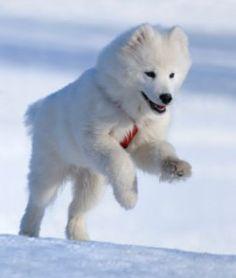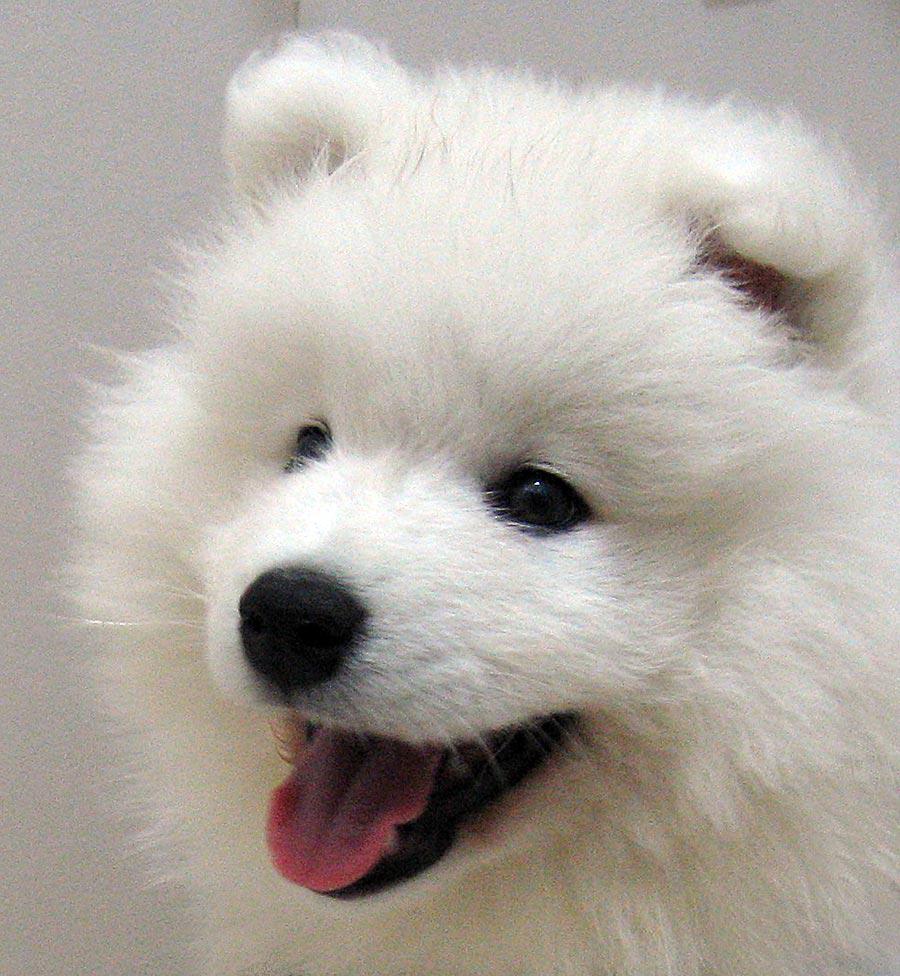The first image is the image on the left, the second image is the image on the right. Analyze the images presented: Is the assertion "Right image features a white dog with its mouth open and tongue showing." valid? Answer yes or no. Yes. The first image is the image on the left, the second image is the image on the right. Examine the images to the left and right. Is the description "The dog on the right has its mouth wide open." accurate? Answer yes or no. Yes. 